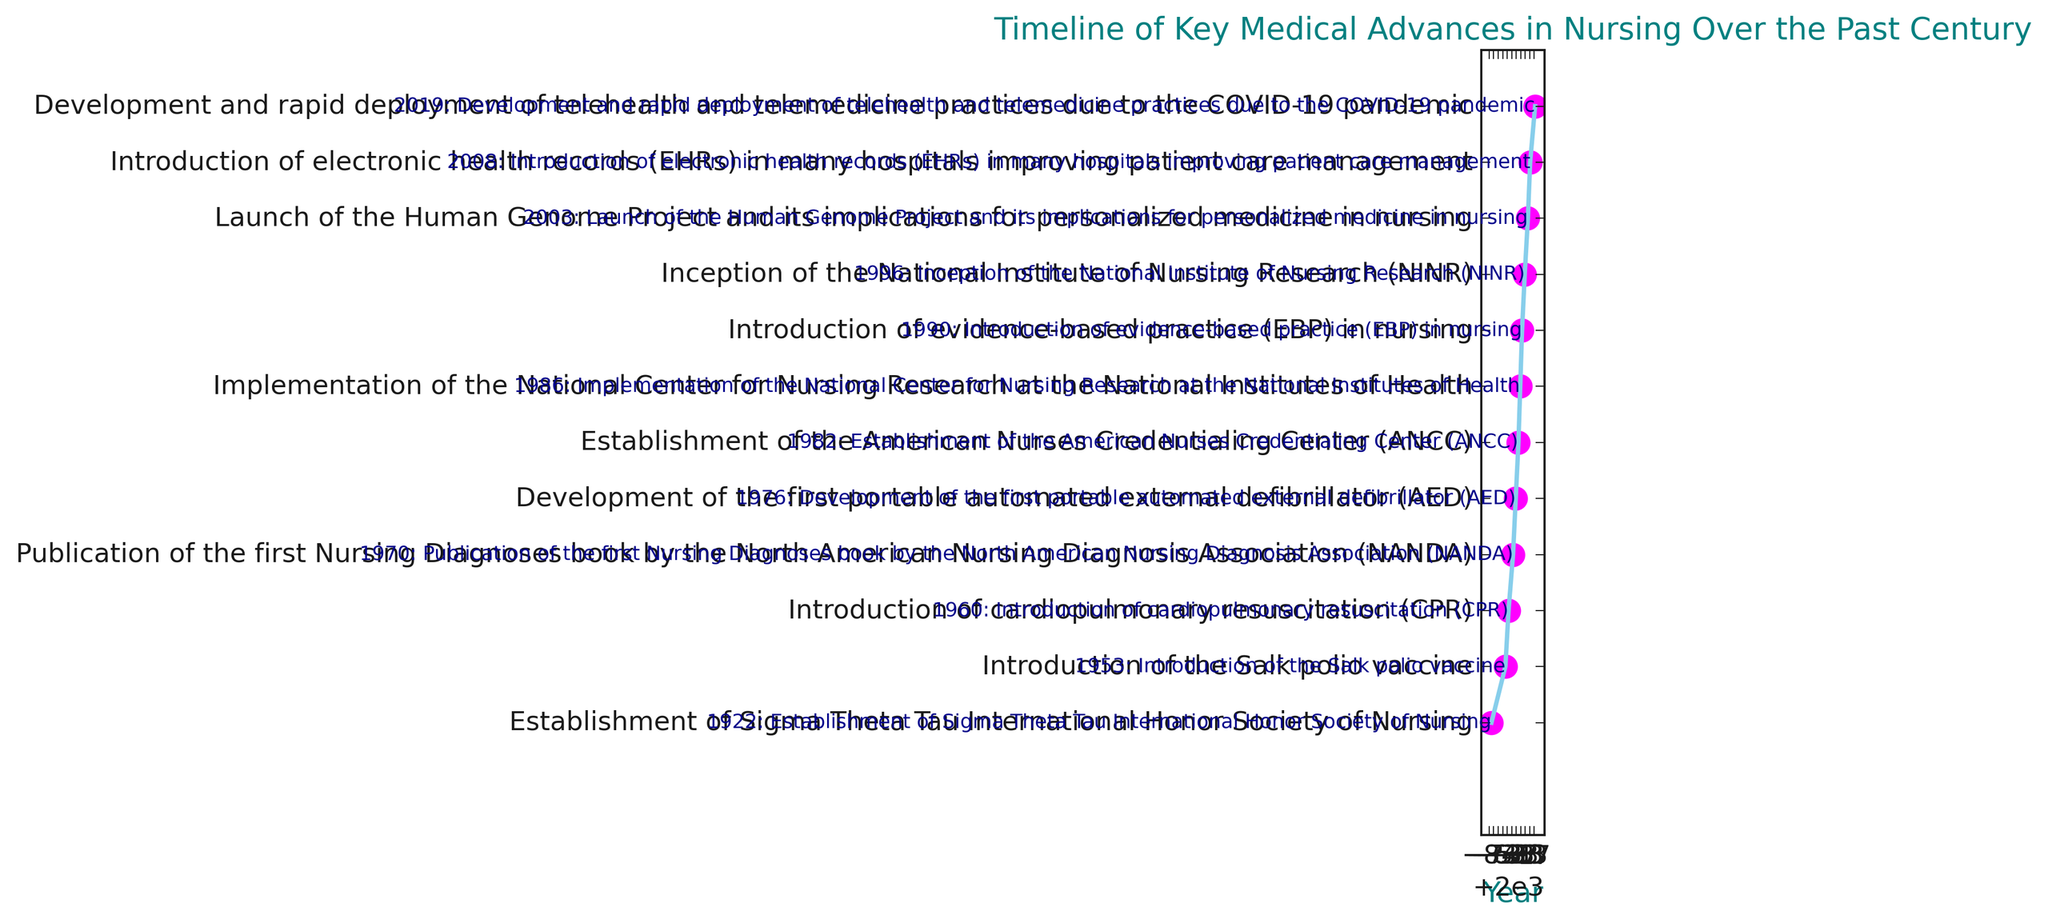What is the earliest key medical advance shown in the timeline? The earliest key medical advance is the first event listed at the beginning of the timeline. The event is at the start of the timeline on the left.
Answer: Establishment of Sigma Theta Tau International Honor Society of Nursing in 1922 How many key medical advances occurred in the 1980s? Count the number of events between 1980 and 1989 on the timeline. There are two events in this decade.
Answer: Two events Which event happened in 1996? Look at the timeline and find the event marked at the year 1996. The event text is written next to the year.
Answer: Inception of the National Institute of Nursing Research (NINR) Which event came before the introduction of evidence-based practice (EBP) in nursing? Locate the introduction of evidence-based practice from the timeline in 1990, and then identify the event occurring just before it.
Answer: Implementation of the National Center for Nursing Research at the NIH in 1986 How many years passed between the introduction of CPR and the development of the first portable AED? Subtract the year of the introduction of CPR (1960) from the year of the development of the AED (1976). The difference gives the duration between these two events.
Answer: 16 years Which event in the timeline corresponds to the year 2003? Look at the timeline to find the year 2003 and read the event associated with it. The event text is written next to the year.
Answer: Launch of the Human Genome Project and its implications for personalized medicine in nursing Compare the number of events before 1960 and after 1960. Which period had more key medical advances? Count the events before and after 1960 on the timeline. There is one event before 1960 and ten events after 1960. Compare the counts to determine which has more.
Answer: After 1960 What is the most recent event on the timeline? Identify the last event listed on the timeline, which corresponds to the latest year shown.
Answer: Development and rapid deployment of telehealth and telemedicine practices in 2019 Which two events are closest to each other in time? Compare the years listed for all events and find the pair of events with the smallest difference between their years. 1982 and 1986 have a difference of 4 years.
Answer: Establishment of ANCC (1982) and Implementation of the National Center for Nursing Research at NIH (1986) What key medical advance is linked to the introduction of the Salk polio vaccine? Locate the Salk polio vaccine introduction in 1953 on the timeline and read the associated event.
Answer: Introduction of the Salk polio vaccine 